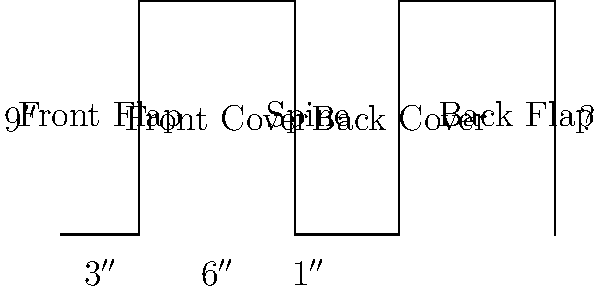As you prepare to share your latest manuscript with close acquaintances, you're considering the dust jacket design. Given the flattened layout of a dust jacket shown above, with the provided dimensions, what is the total width of the unfolded dust jacket in inches? To calculate the total width of the unfolded dust jacket, we need to add up the widths of all its components:

1. Front flap: $3''$
2. Front cover: $6''$
3. Spine: $1''$
4. Back cover: $6''$ (same as front cover)
5. Back flap: $3''$ (same as front flap)

Step-by-step calculation:
1. Total width = Front flap + Front cover + Spine + Back cover + Back flap
2. Total width = $3'' + 6'' + 1'' + 6'' + 3''$
3. Total width = $19''$

Therefore, the total width of the unfolded dust jacket is 19 inches.
Answer: $19''$ 